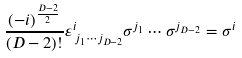<formula> <loc_0><loc_0><loc_500><loc_500>\frac { ( - i ) ^ { \frac { D - 2 } { 2 } } } { ( D - 2 ) ! } \varepsilon ^ { i } _ { \, j _ { 1 } \cdots j _ { D - 2 } } \sigma ^ { j _ { 1 } } \cdots \sigma ^ { j _ { D - 2 } } = \sigma ^ { i }</formula> 